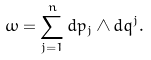Convert formula to latex. <formula><loc_0><loc_0><loc_500><loc_500>\omega = \sum _ { j = 1 } ^ { n } d p _ { j } \wedge d q ^ { j } .</formula> 